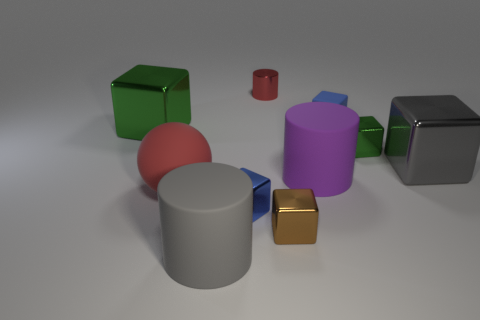How many small brown blocks have the same material as the large red ball?
Your answer should be compact. 0. There is a cube that is behind the big green shiny block; is its size the same as the green block to the left of the red shiny thing?
Give a very brief answer. No. The large metallic cube that is on the right side of the brown cube is what color?
Ensure brevity in your answer.  Gray. There is a ball that is the same color as the shiny cylinder; what is it made of?
Your answer should be very brief. Rubber. What number of balls have the same color as the tiny matte thing?
Keep it short and to the point. 0. Is the size of the gray matte thing the same as the cylinder that is right of the brown thing?
Ensure brevity in your answer.  Yes. There is a matte thing that is behind the big metallic thing on the left side of the red thing behind the rubber block; what is its size?
Your answer should be very brief. Small. What number of large blocks are on the right side of the tiny metal cylinder?
Your response must be concise. 1. What material is the blue object that is behind the gray object behind the tiny blue metal thing?
Provide a short and direct response. Rubber. Is the size of the red rubber sphere the same as the gray shiny block?
Your answer should be compact. Yes. 